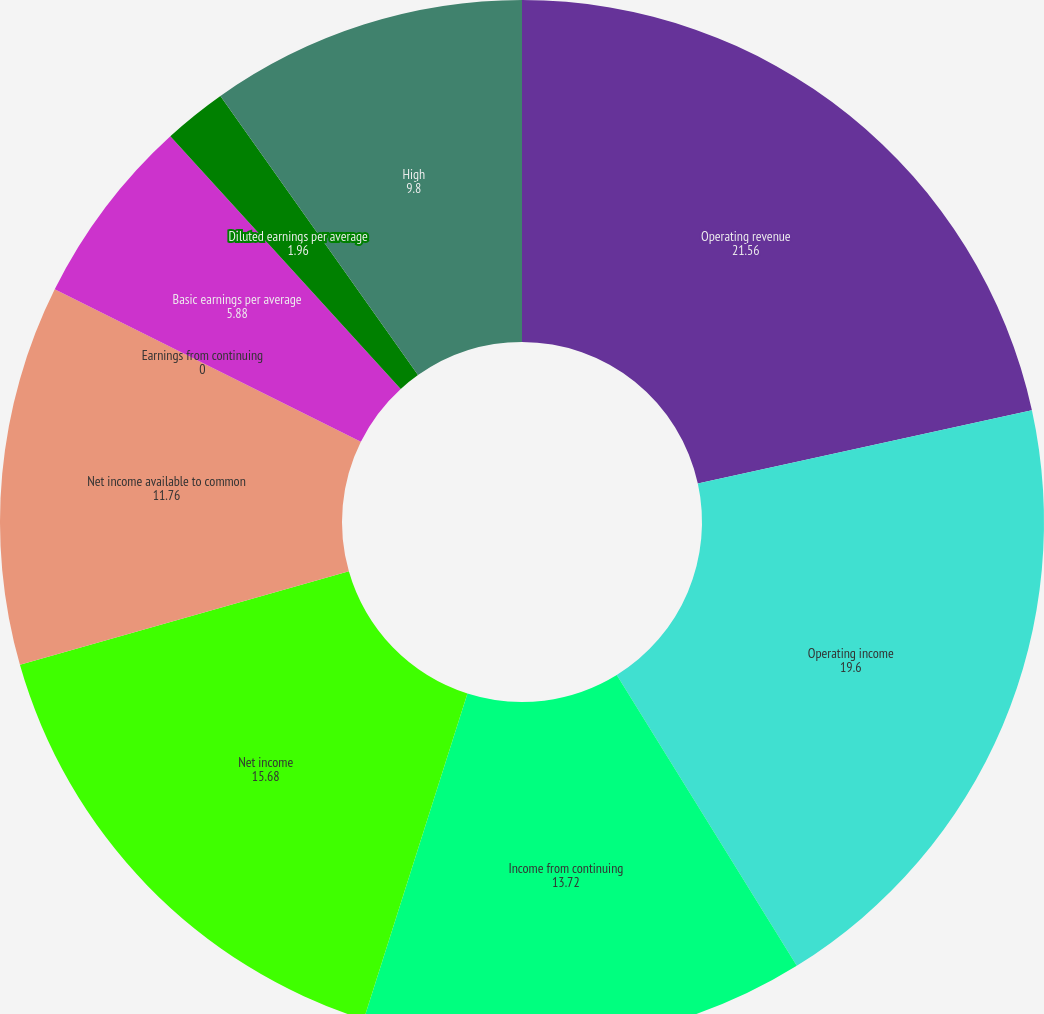Convert chart to OTSL. <chart><loc_0><loc_0><loc_500><loc_500><pie_chart><fcel>Operating revenue<fcel>Operating income<fcel>Income from continuing<fcel>Net income<fcel>Net income available to common<fcel>Earnings from continuing<fcel>Basic earnings per average<fcel>Diluted earnings per average<fcel>High<nl><fcel>21.56%<fcel>19.6%<fcel>13.72%<fcel>15.68%<fcel>11.76%<fcel>0.0%<fcel>5.88%<fcel>1.96%<fcel>9.8%<nl></chart> 